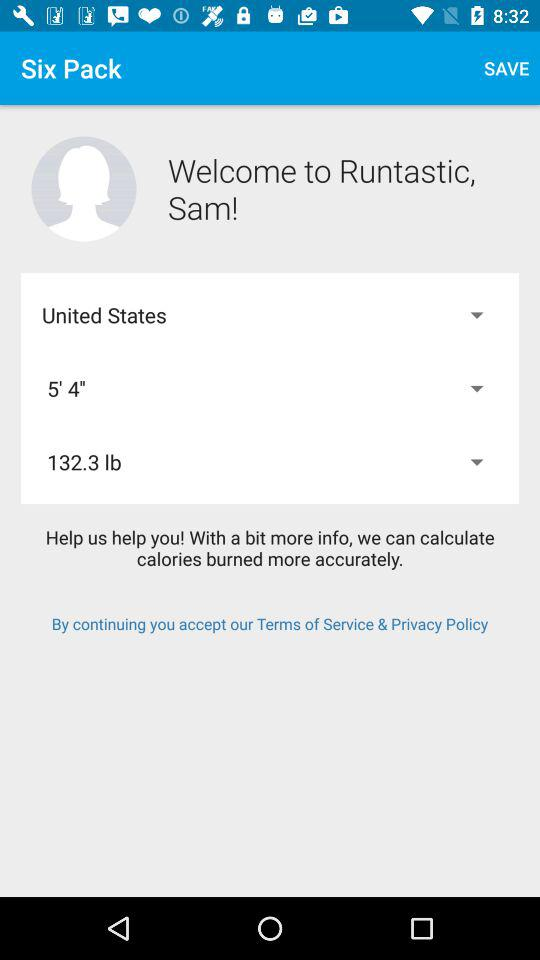What is the name of the user? The name of the user is Sam. 